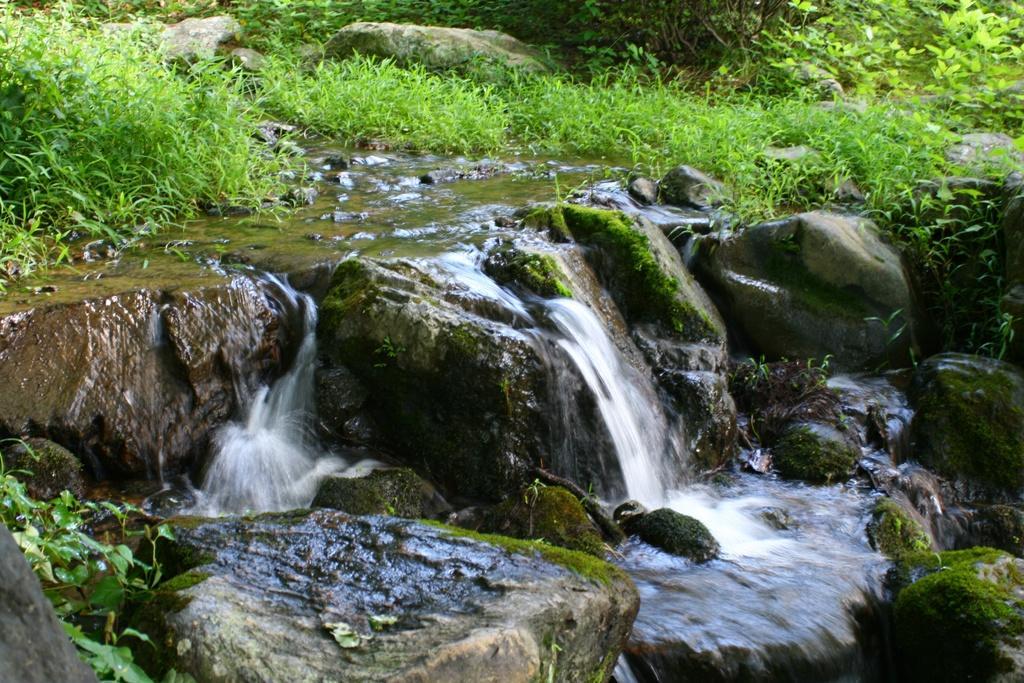Can you describe this image briefly? In this image, we can see a small waterfalls, plants and rocks. 